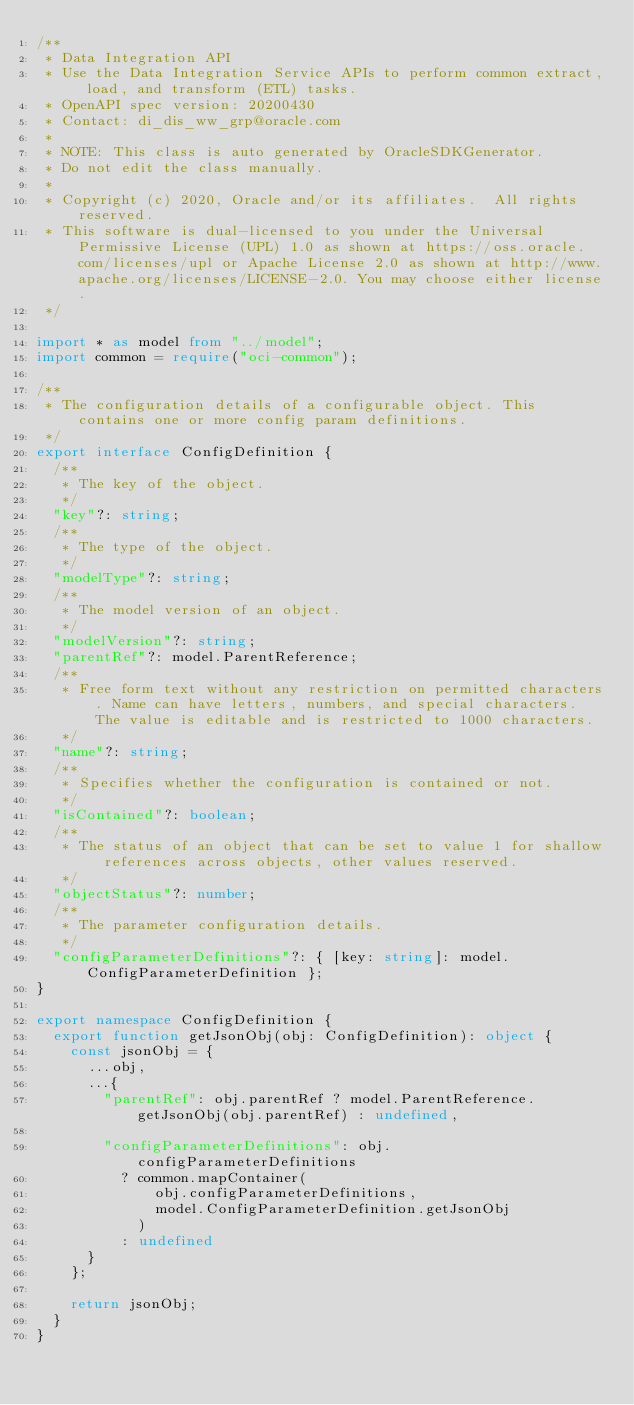<code> <loc_0><loc_0><loc_500><loc_500><_TypeScript_>/**
 * Data Integration API
 * Use the Data Integration Service APIs to perform common extract, load, and transform (ETL) tasks.
 * OpenAPI spec version: 20200430
 * Contact: di_dis_ww_grp@oracle.com
 *
 * NOTE: This class is auto generated by OracleSDKGenerator.
 * Do not edit the class manually.
 *
 * Copyright (c) 2020, Oracle and/or its affiliates.  All rights reserved.
 * This software is dual-licensed to you under the Universal Permissive License (UPL) 1.0 as shown at https://oss.oracle.com/licenses/upl or Apache License 2.0 as shown at http://www.apache.org/licenses/LICENSE-2.0. You may choose either license.
 */

import * as model from "../model";
import common = require("oci-common");

/**
 * The configuration details of a configurable object. This contains one or more config param definitions.
 */
export interface ConfigDefinition {
  /**
   * The key of the object.
   */
  "key"?: string;
  /**
   * The type of the object.
   */
  "modelType"?: string;
  /**
   * The model version of an object.
   */
  "modelVersion"?: string;
  "parentRef"?: model.ParentReference;
  /**
   * Free form text without any restriction on permitted characters. Name can have letters, numbers, and special characters. The value is editable and is restricted to 1000 characters.
   */
  "name"?: string;
  /**
   * Specifies whether the configuration is contained or not.
   */
  "isContained"?: boolean;
  /**
   * The status of an object that can be set to value 1 for shallow references across objects, other values reserved.
   */
  "objectStatus"?: number;
  /**
   * The parameter configuration details.
   */
  "configParameterDefinitions"?: { [key: string]: model.ConfigParameterDefinition };
}

export namespace ConfigDefinition {
  export function getJsonObj(obj: ConfigDefinition): object {
    const jsonObj = {
      ...obj,
      ...{
        "parentRef": obj.parentRef ? model.ParentReference.getJsonObj(obj.parentRef) : undefined,

        "configParameterDefinitions": obj.configParameterDefinitions
          ? common.mapContainer(
              obj.configParameterDefinitions,
              model.ConfigParameterDefinition.getJsonObj
            )
          : undefined
      }
    };

    return jsonObj;
  }
}
</code> 